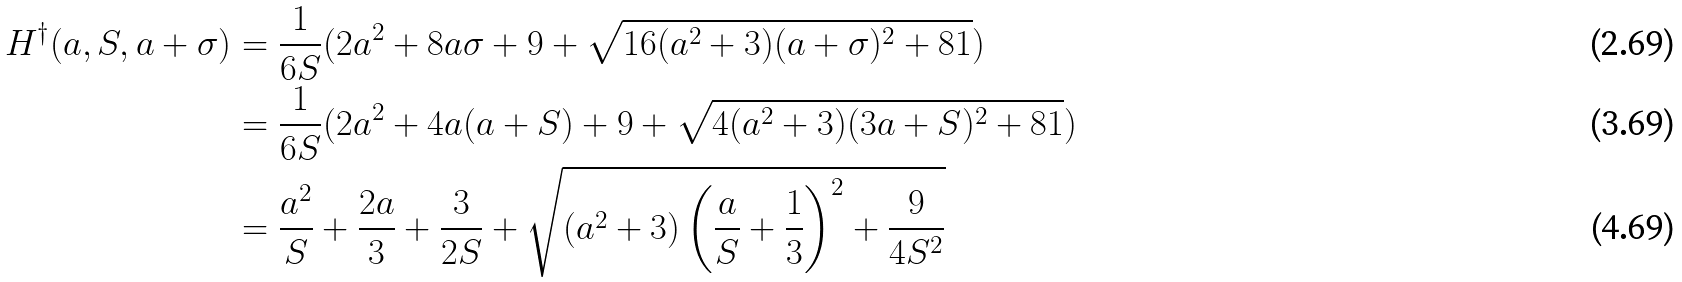Convert formula to latex. <formula><loc_0><loc_0><loc_500><loc_500>H ^ { \dagger } ( a , S , a + \sigma ) & = \frac { 1 } { 6 S } ( 2 a ^ { 2 } + 8 a \sigma + 9 + \sqrt { 1 6 ( a ^ { 2 } + 3 ) ( a + \sigma ) ^ { 2 } + 8 1 } ) \\ & = \frac { 1 } { 6 S } ( 2 a ^ { 2 } + 4 a ( a + S ) + 9 + \sqrt { 4 ( a ^ { 2 } + 3 ) ( 3 a + S ) ^ { 2 } + 8 1 } ) \\ & = \frac { a ^ { 2 } } { S } + \frac { 2 a } { 3 } + \frac { 3 } { 2 S } + \sqrt { \left ( a ^ { 2 } + 3 \right ) \left ( \frac { a } { S } + \frac { 1 } { 3 } \right ) ^ { 2 } + \frac { 9 } { 4 S ^ { 2 } } }</formula> 